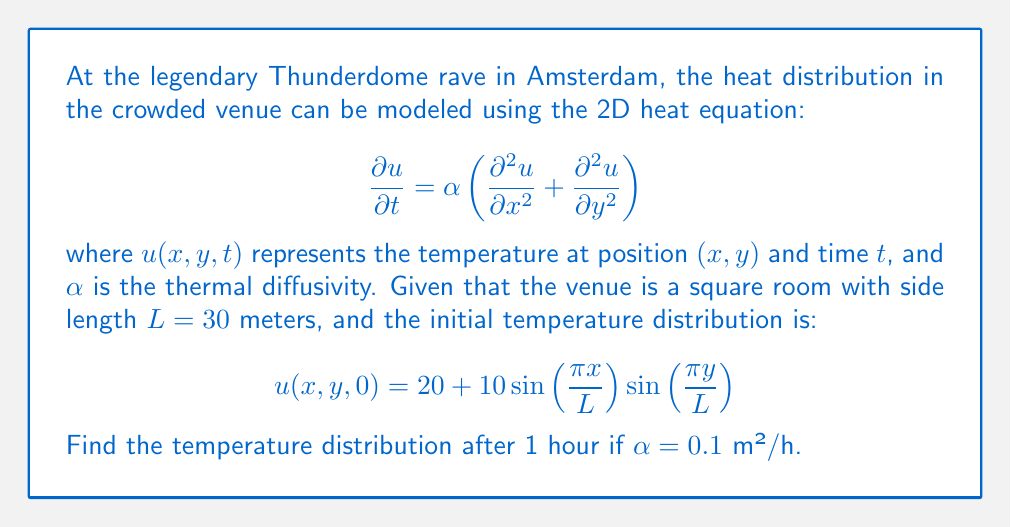Can you solve this math problem? To solve this problem, we'll use the method of separation of variables:

1) Assume a solution of the form: $u(x,y,t) = X(x)Y(y)T(t)$

2) Substituting into the heat equation and separating variables:

   $$\frac{T'(t)}{αT(t)} = \frac{X''(x)}{X(x)} + \frac{Y''(y)}{Y(y)} = -k^2$$

3) This leads to three ODEs:
   
   $$T'(t) + αk^2T(t) = 0$$
   $$X''(x) + λ^2X(x) = 0$$
   $$Y''(y) + μ^2Y(y) = 0$$

   where $k^2 = λ^2 + μ^2$

4) Given the boundary conditions (insulated walls), we get:
   
   $$X(x) = \sin\left(\frac{nπx}{L}\right), λ = \frac{nπ}{L}$$
   $$Y(y) = \sin\left(\frac{mπy}{L}\right), μ = \frac{mπ}{L}$$

5) The general solution is:

   $$u(x,y,t) = \sum_{n=1}^{\infty}\sum_{m=1}^{\infty} A_{nm} \sin\left(\frac{nπx}{L}\right)\sin\left(\frac{mπy}{L}\right)e^{-α(λ^2+μ^2)t}$$

6) Comparing with the initial condition, we see that only $n=m=1$ term is non-zero:

   $$A_{11} = 10, A_{nm} = 0 \text{ for } (n,m) \neq (1,1)$$

7) Therefore, the solution is:

   $$u(x,y,t) = 20 + 10\sin\left(\frac{\pi x}{L}\right)\sin\left(\frac{\pi y}{L}\right)e^{-2α(\frac{\pi}{L})^2t}$$

8) Plugging in the values:
   
   $$u(x,y,1) = 20 + 10\sin\left(\frac{\pi x}{30}\right)\sin\left(\frac{\pi y}{30}\right)e^{-2(0.1)(\frac{\pi}{30})^2(1)}$$
Answer: $u(x,y,1) = 20 + 9.78\sin\left(\frac{\pi x}{30}\right)\sin\left(\frac{\pi y}{30}\right)$ 